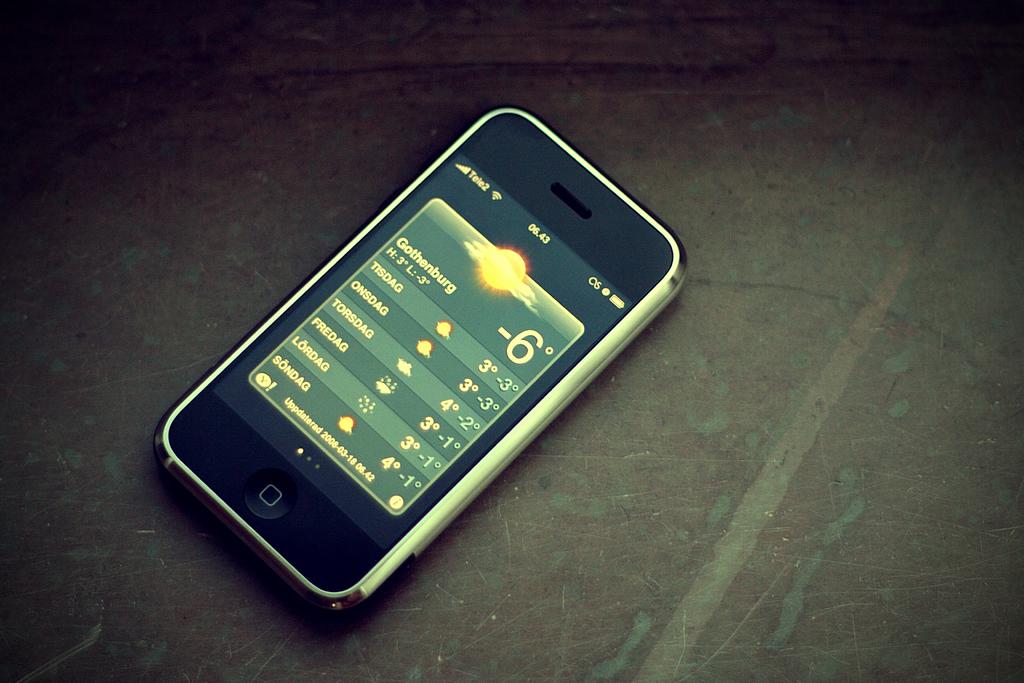What is the name of the city on the weather app?
Provide a succinct answer. Gothenburg. 